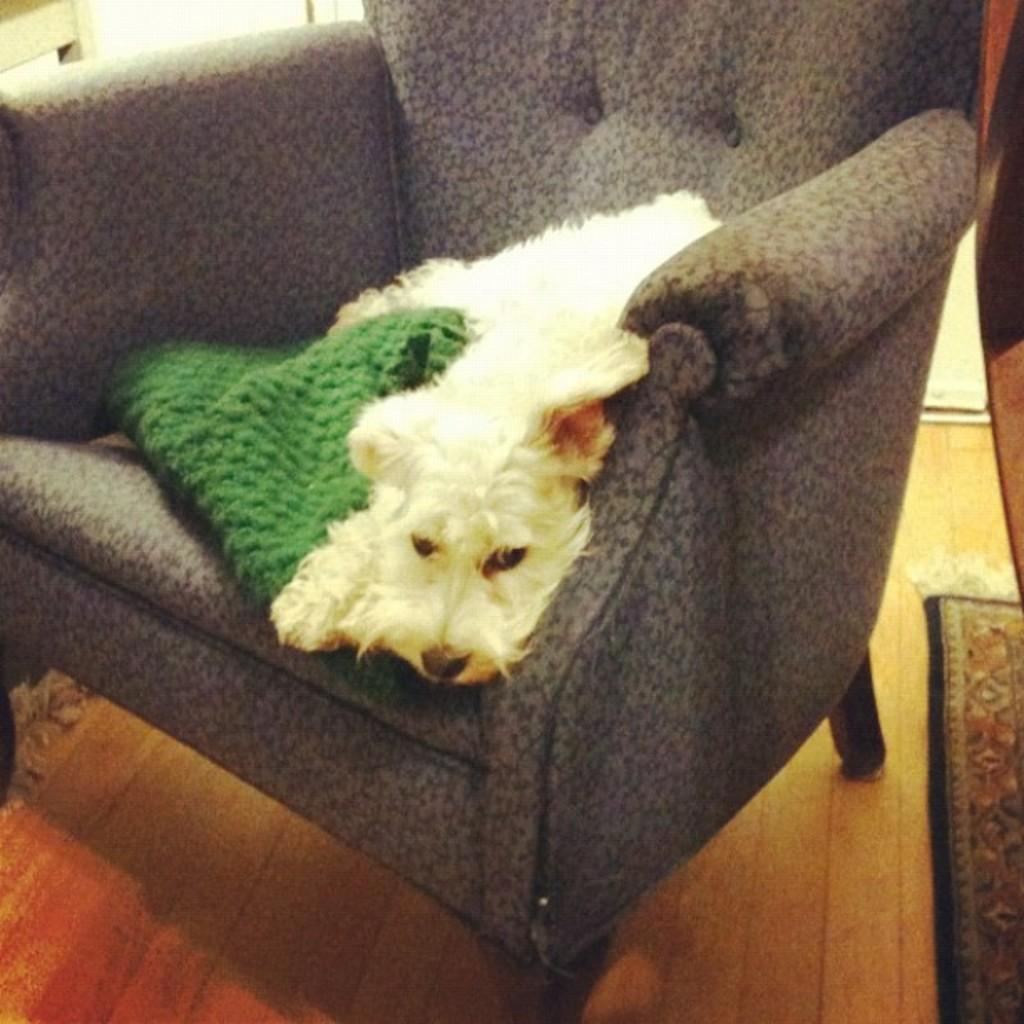What object can be seen in the image that people typically sit on? There is a chair in the image that people typically sit on. What animal is sitting on the chair? A: A dog is sitting on the chair. What item is located near the chair? There is a cloth beside the chair. What can be seen on the right side of the image? There is a door mat on the right side of the image. What type of necklace is the dog wearing in the image? There is no necklace or any jewelry visible on the dog in the image. 